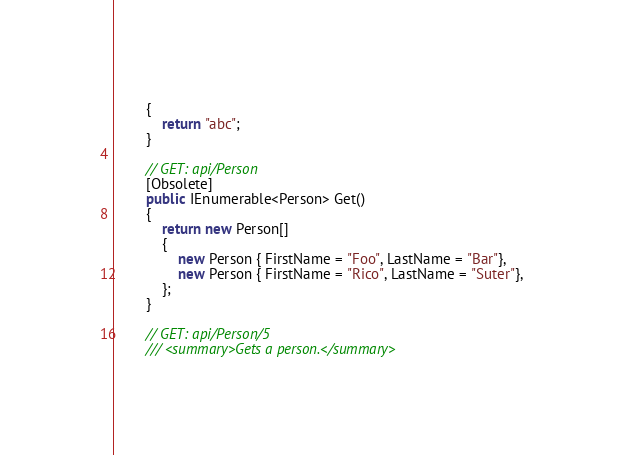Convert code to text. <code><loc_0><loc_0><loc_500><loc_500><_C#_>        {
            return "abc";
        }

        // GET: api/Person
        [Obsolete]
        public IEnumerable<Person> Get()
        {
            return new Person[]
            {
                new Person { FirstName = "Foo", LastName = "Bar"},
                new Person { FirstName = "Rico", LastName = "Suter"},
            };
        }

        // GET: api/Person/5
        /// <summary>Gets a person.</summary></code> 